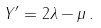Convert formula to latex. <formula><loc_0><loc_0><loc_500><loc_500>Y ^ { \prime } = 2 \lambda - \mu \, .</formula> 